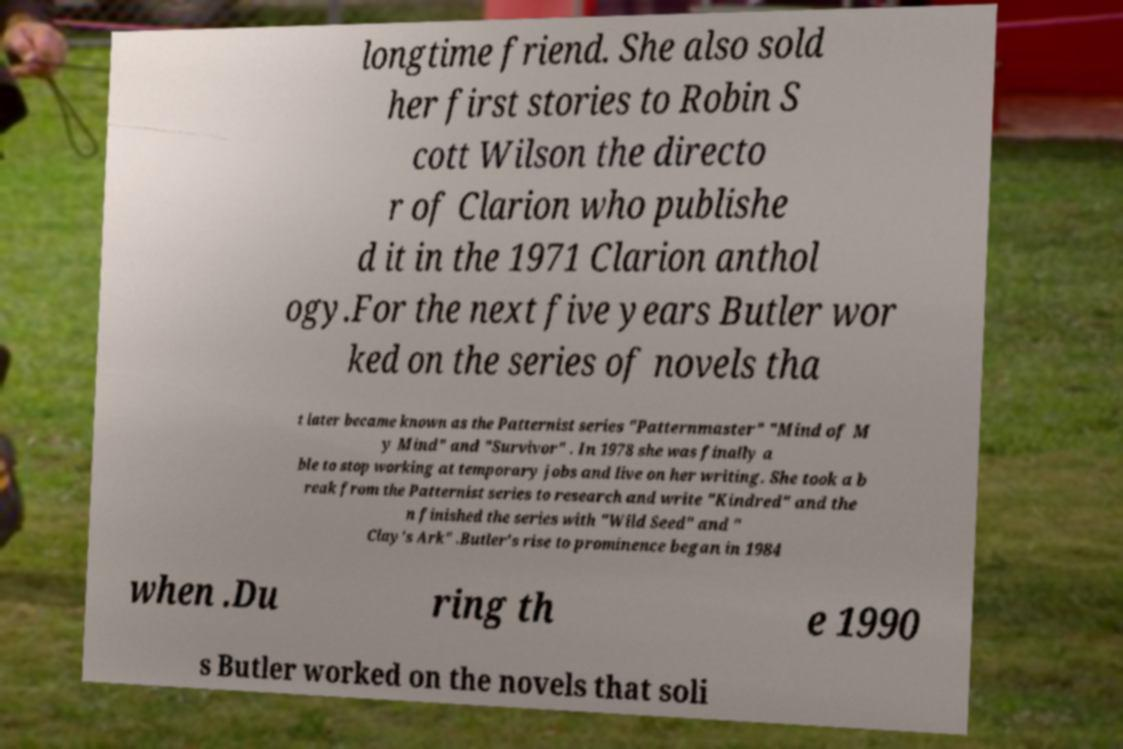What messages or text are displayed in this image? I need them in a readable, typed format. longtime friend. She also sold her first stories to Robin S cott Wilson the directo r of Clarion who publishe d it in the 1971 Clarion anthol ogy.For the next five years Butler wor ked on the series of novels tha t later became known as the Patternist series "Patternmaster" "Mind of M y Mind" and "Survivor" . In 1978 she was finally a ble to stop working at temporary jobs and live on her writing. She took a b reak from the Patternist series to research and write "Kindred" and the n finished the series with "Wild Seed" and " Clay's Ark" .Butler's rise to prominence began in 1984 when .Du ring th e 1990 s Butler worked on the novels that soli 